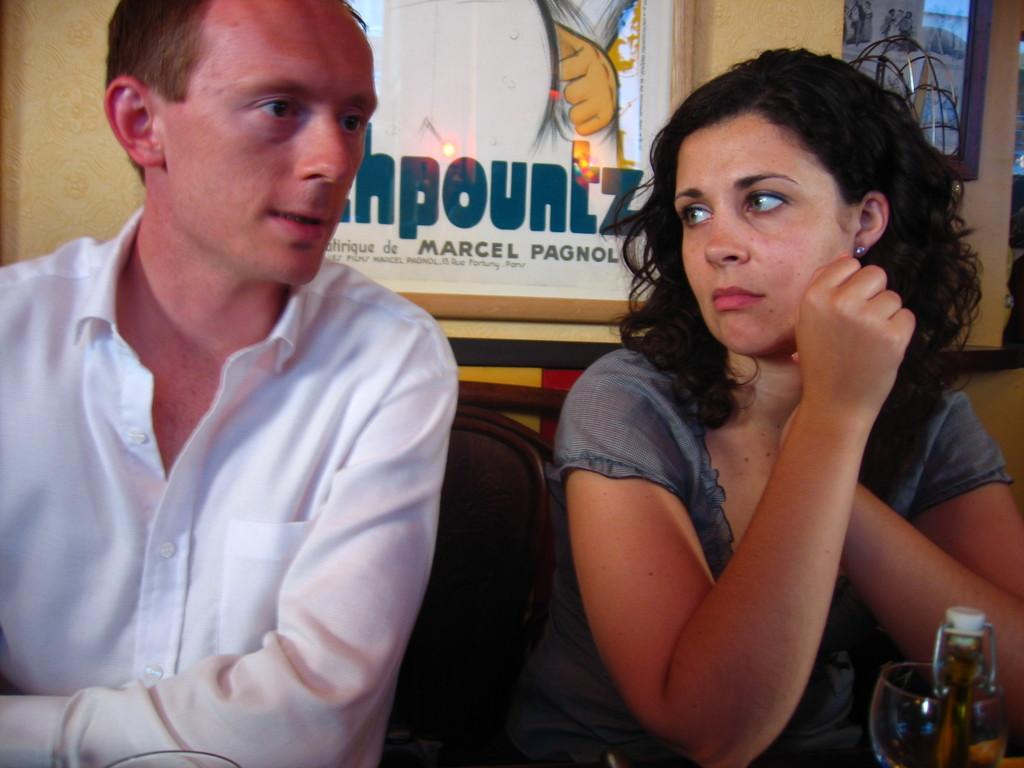Who can be seen in the image? There is a couple in the image. What is the man wearing? The man is wearing a white shirt. What is the woman wearing? The woman is wearing an ash color dress. What are they doing in the image? The couple is sitting in chairs. Where are they sitting? They are at a table. What is on the table? There are glasses on the table. What can be seen behind the couple? There is a poster behind them. What type of fowl can be seen on the table in the image? There is no fowl present on the table in the image. What attraction is the couple visiting in the image? The image does not provide information about the couple visiting any specific attraction. 